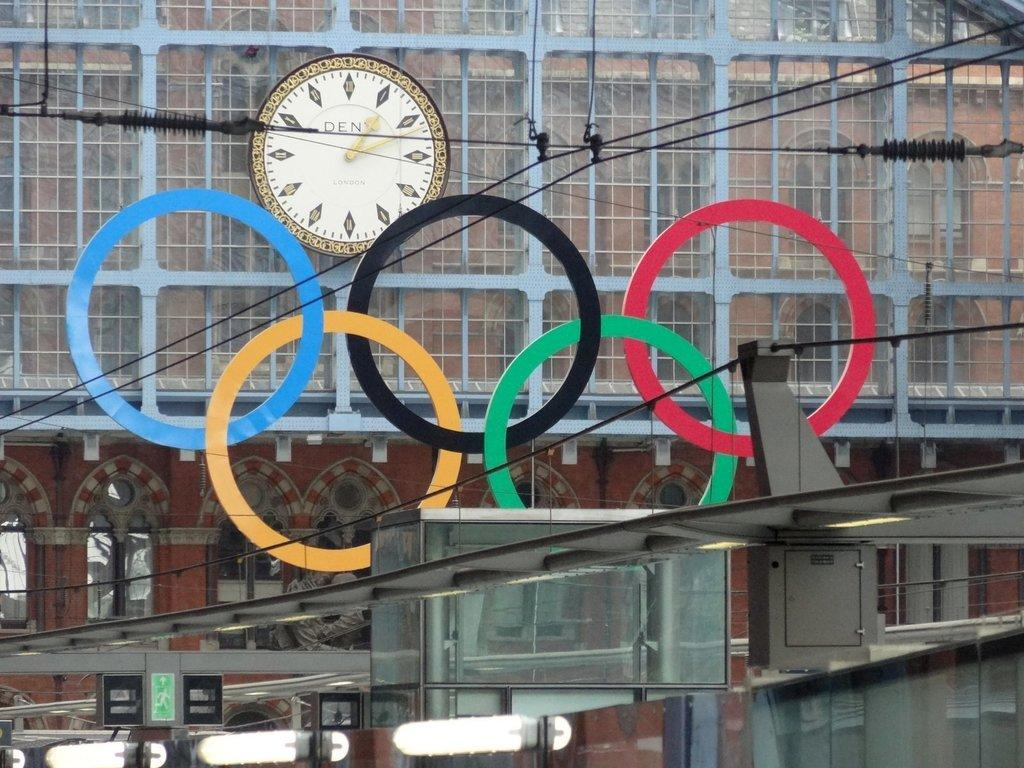<image>
Give a short and clear explanation of the subsequent image. The olympic rings in front of a Dent clock 